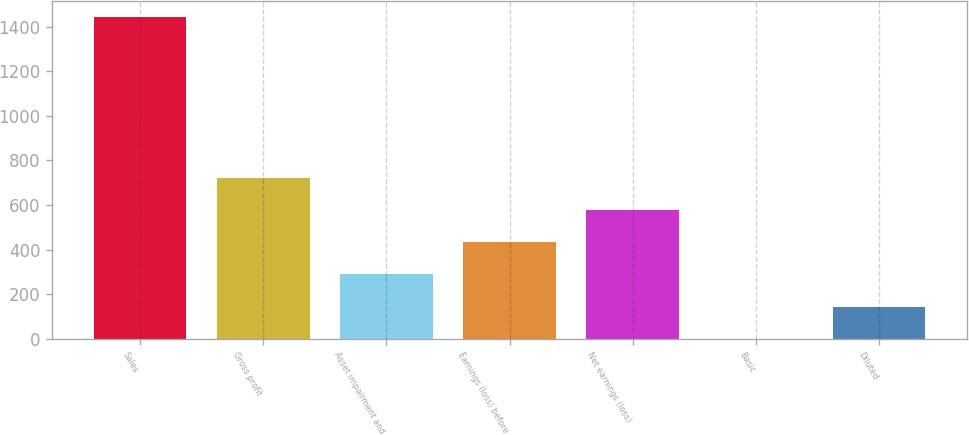Convert chart to OTSL. <chart><loc_0><loc_0><loc_500><loc_500><bar_chart><fcel>Sales<fcel>Gross profit<fcel>Asset impairment and<fcel>Earnings (loss) before<fcel>Net earnings (loss)<fcel>Basic<fcel>Diluted<nl><fcel>1441<fcel>720.63<fcel>288.39<fcel>432.47<fcel>576.55<fcel>0.23<fcel>144.31<nl></chart> 